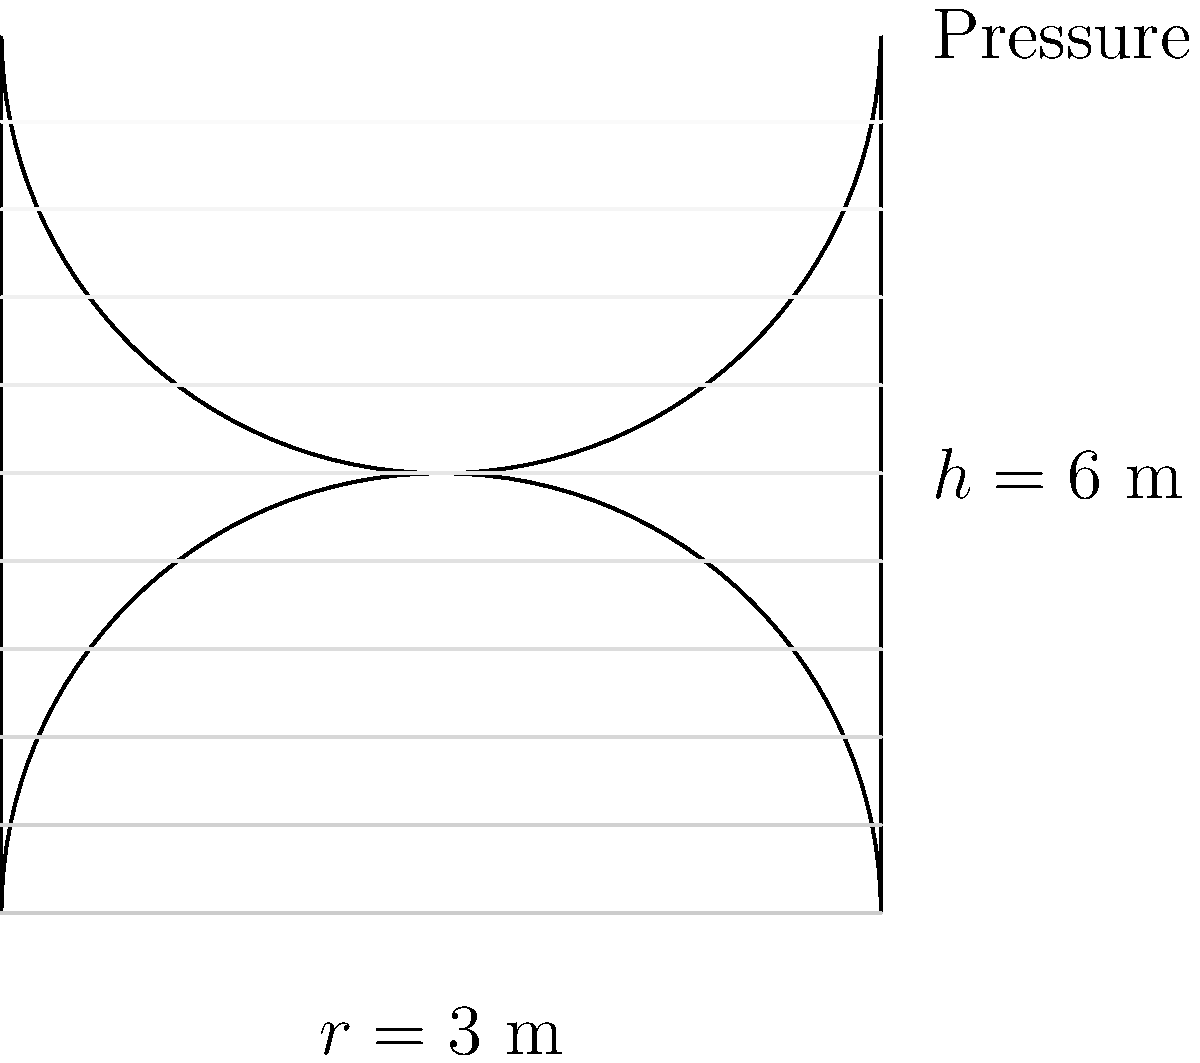A cylindrical biofuel storage tank has a radius of 3 meters and a height of 6 meters. The tank is made of steel with a yield strength of 250 MPa and is filled with a biofuel of density 850 kg/m³. Calculate the maximum hoop stress at the bottom of the tank. Assume the tank wall thickness is much smaller than its radius. To calculate the maximum hoop stress at the bottom of the tank, we'll follow these steps:

1) First, calculate the pressure at the bottom of the tank:
   $P = \rho g h$
   where $\rho$ is the density of the biofuel, $g$ is the acceleration due to gravity, and $h$ is the height of the tank.

   $P = 850 \text{ kg/m³} \times 9.81 \text{ m/s²} \times 6 \text{ m} = 50,031 \text{ Pa}$

2) The hoop stress in a thin-walled cylindrical pressure vessel is given by:
   $\sigma_{\theta} = \frac{Pr}{t}$
   where $P$ is the pressure, $r$ is the radius of the tank, and $t$ is the wall thickness.

3) We don't know the wall thickness, but we can assume it's much smaller than the radius. The maximum hoop stress will occur at the bottom of the tank where the pressure is highest.

4) Substituting the values we know:
   $\sigma_{\theta} = \frac{50,031 \text{ Pa} \times 3 \text{ m}}{t}$

5) This gives us the maximum hoop stress in terms of the wall thickness $t$. The actual stress will depend on the chosen wall thickness, which would be determined based on the yield strength of the steel and a suitable safety factor.
Answer: $\sigma_{\theta} = \frac{150,093}{t} \text{ Pa}$, where $t$ is the wall thickness in meters. 